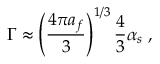Convert formula to latex. <formula><loc_0><loc_0><loc_500><loc_500>\Gamma \approx \left ( \frac { 4 \pi a _ { f } } { 3 } \right ) ^ { 1 / 3 } \frac { 4 } { 3 } \alpha _ { s } \, ,</formula> 